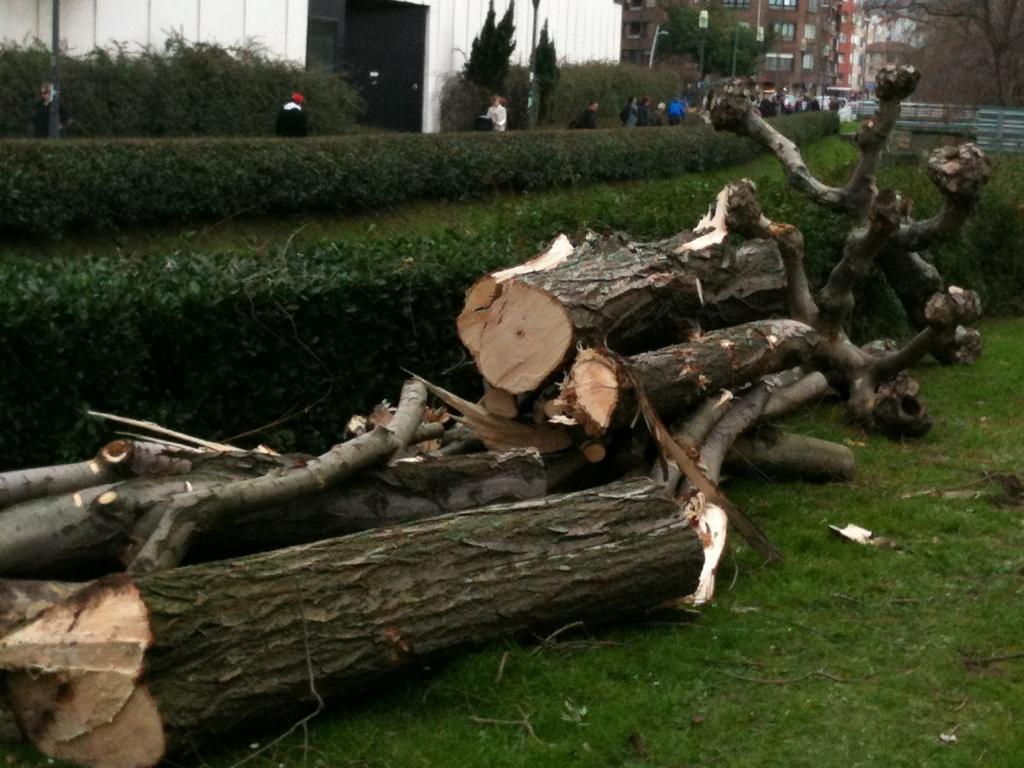Describe this image in one or two sentences. This is an outside view. Here I can see many trunks on the ground. In the background there are many plants and also I can see the people walking. At the top of the image there are many trees and buildings. On the ground, I can see the grass. 